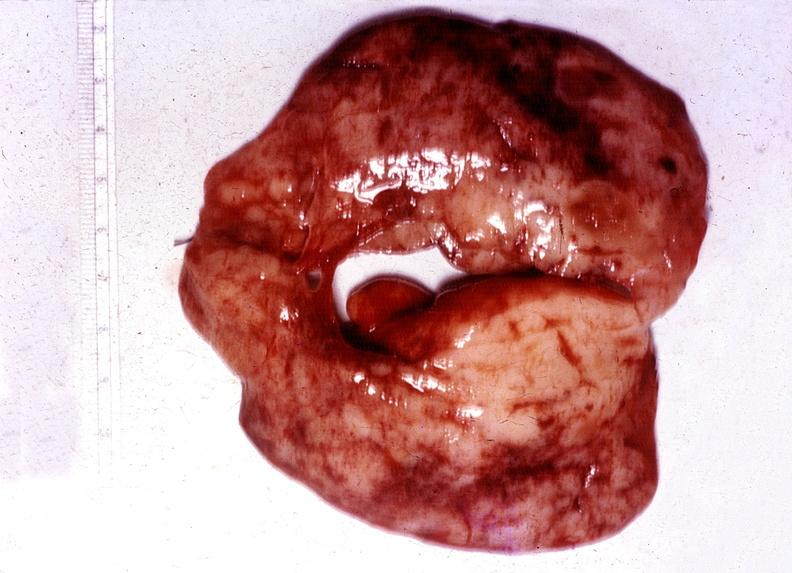s fibrinous peritonitis present?
Answer the question using a single word or phrase. No 